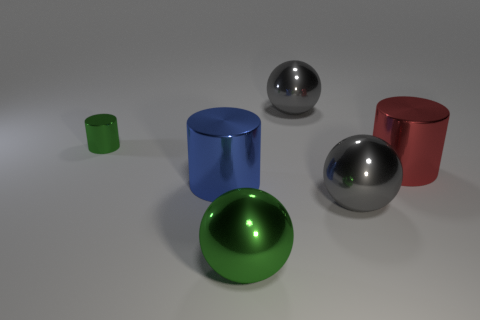How many gray spheres must be subtracted to get 1 gray spheres? 1 Add 1 large red shiny objects. How many objects exist? 7 Subtract 0 red blocks. How many objects are left? 6 Subtract all small red matte spheres. Subtract all red things. How many objects are left? 5 Add 5 blue metallic things. How many blue metallic things are left? 6 Add 4 blue objects. How many blue objects exist? 5 